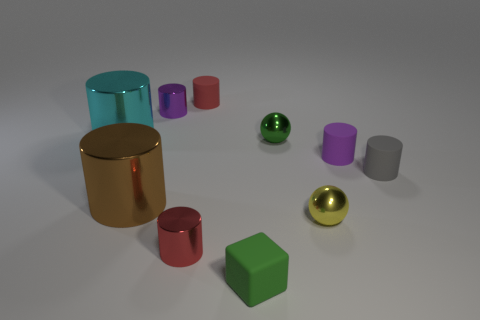The red metal object that is the same shape as the tiny purple metal thing is what size?
Provide a succinct answer. Small. What number of large yellow blocks have the same material as the cyan cylinder?
Offer a terse response. 0. Are there any small red metal objects that are to the right of the matte thing left of the matte object in front of the big brown cylinder?
Keep it short and to the point. No. The purple matte object is what shape?
Give a very brief answer. Cylinder. Is the material of the tiny purple cylinder in front of the cyan metal thing the same as the green thing to the right of the tiny block?
Your answer should be very brief. No. What number of tiny balls have the same color as the matte block?
Offer a terse response. 1. The small object that is on the right side of the yellow thing and to the left of the small gray matte object has what shape?
Provide a succinct answer. Cylinder. What color is the small thing that is right of the purple shiny cylinder and behind the cyan cylinder?
Ensure brevity in your answer.  Red. Is the number of tiny purple cylinders that are left of the small purple metal cylinder greater than the number of cylinders in front of the small gray matte cylinder?
Provide a short and direct response. No. There is a matte cylinder left of the green rubber cube; what is its color?
Offer a very short reply. Red. 